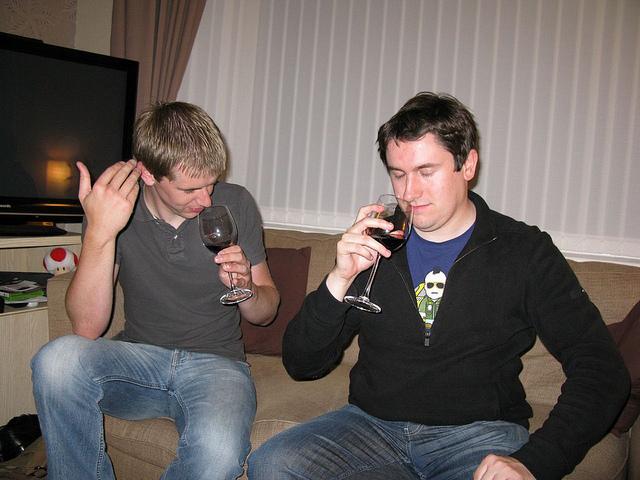Where is the man on the right looking?
Be succinct. Down. What are they drinking?
Keep it brief. Wine. What are these people's attention most likely fixated on?
Short answer required. Wine. Are there blinds in the image?
Quick response, please. Yes. 